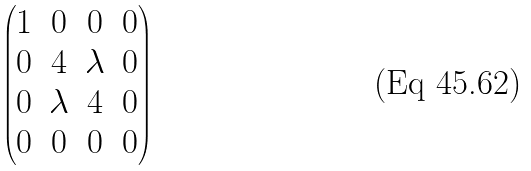<formula> <loc_0><loc_0><loc_500><loc_500>\begin{pmatrix} 1 & 0 & 0 & 0 \\ 0 & 4 & \lambda & 0 \\ 0 & \lambda & 4 & 0 \\ 0 & 0 & 0 & 0 \end{pmatrix}</formula> 